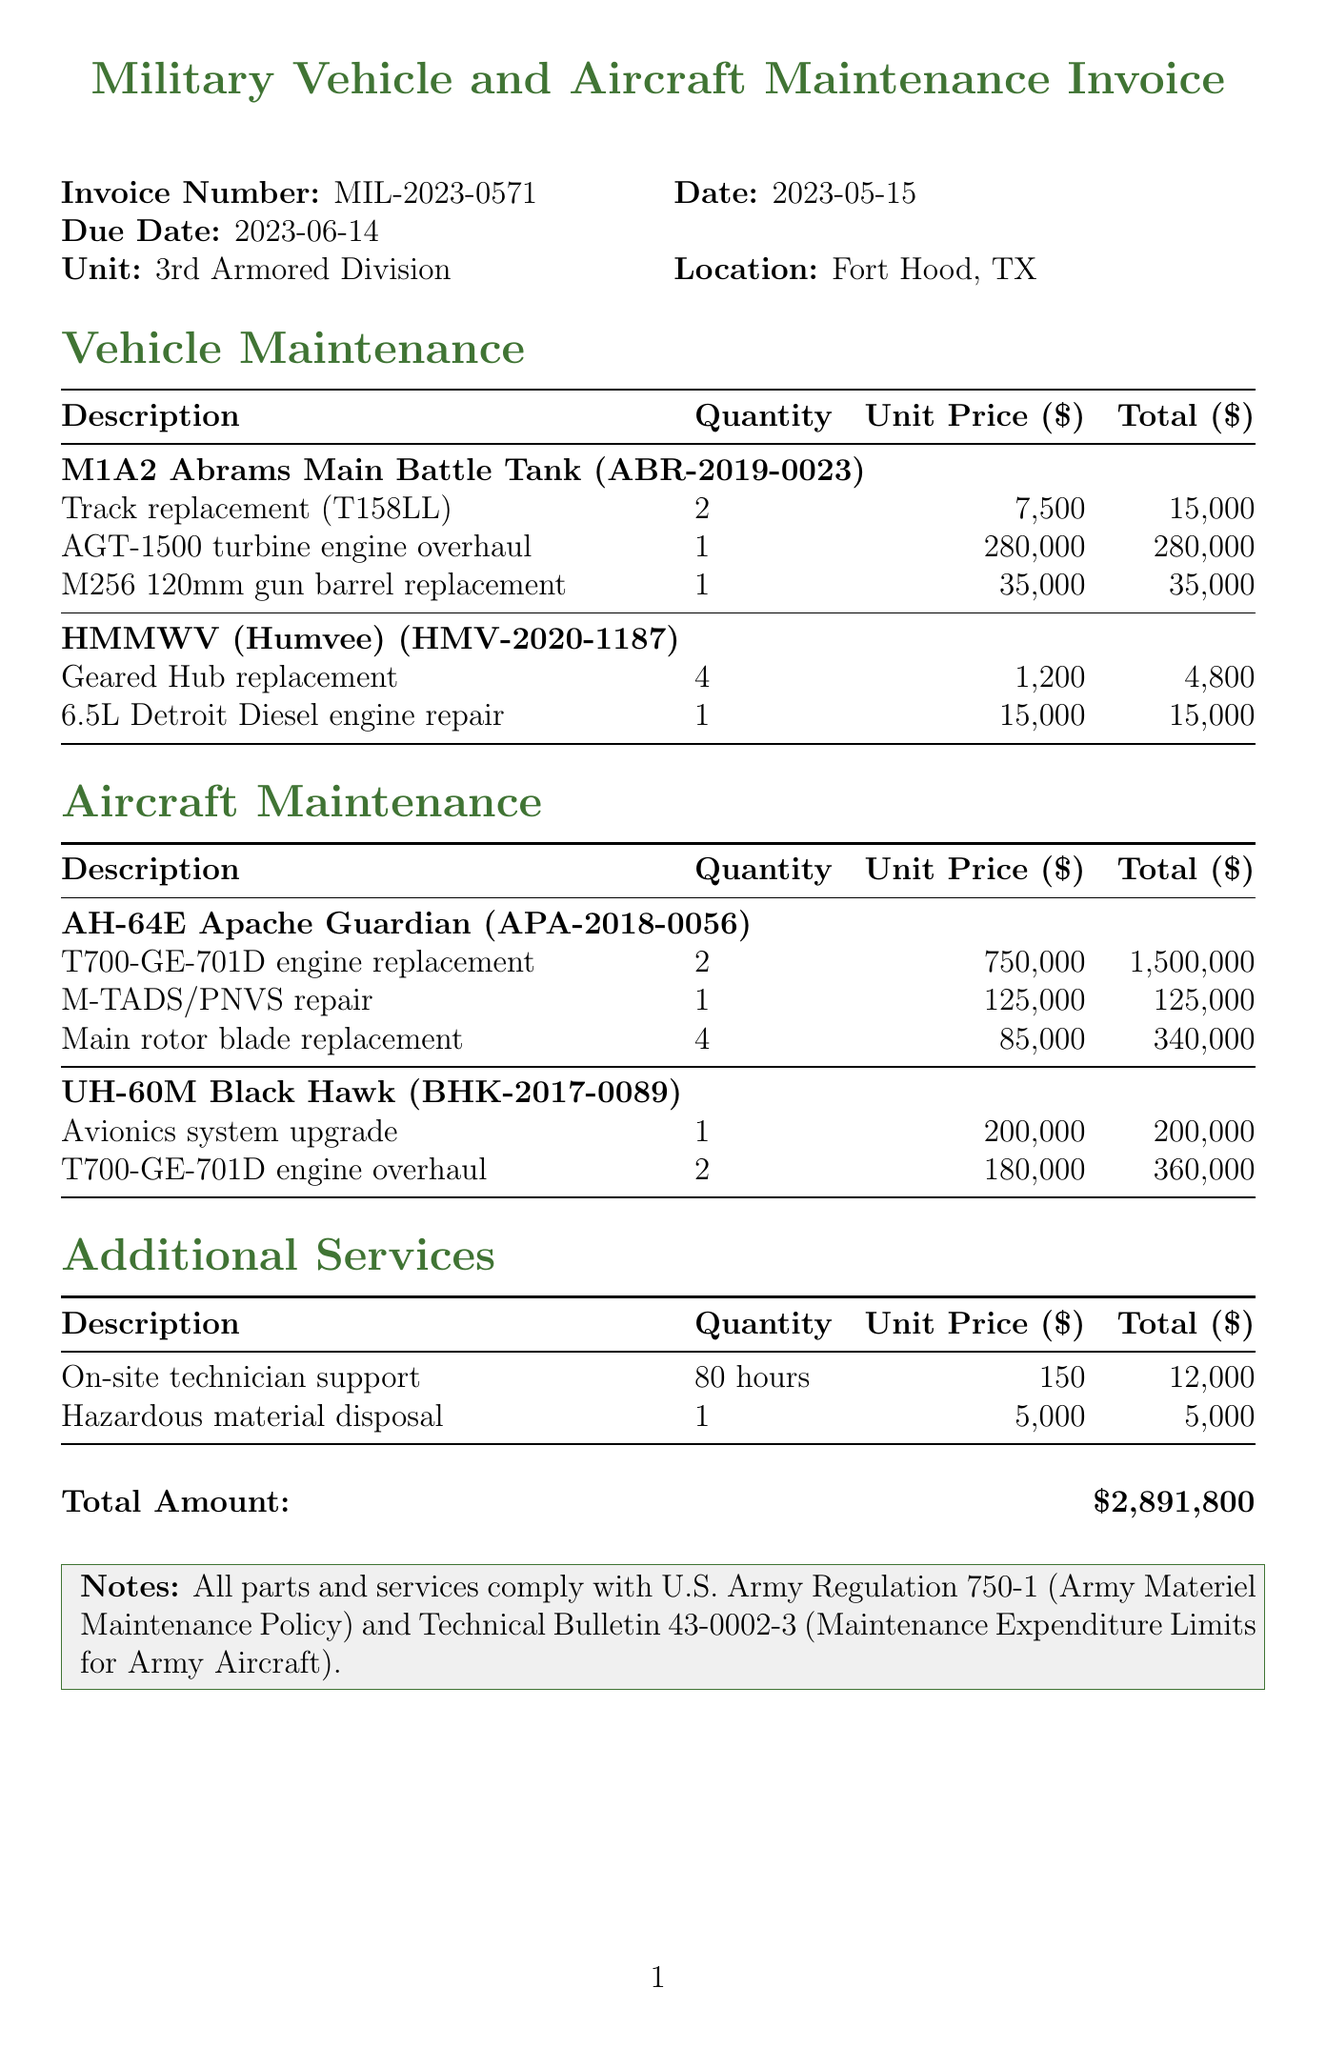What is the invoice number? The invoice number is provided at the top of the document, labeled clearly.
Answer: MIL-2023-0571 What is the total amount due? The total amount is listed at the bottom of the document, indicating the total cost of services rendered.
Answer: $2,891,800 What is the due date for payment? The due date is specified on the invoice alongside the issue date and other details.
Answer: 2023-06-14 How many hours of on-site technician support were billed? The document specifies the quantity of hours for this service in the additional services section.
Answer: 80 hours What type of vehicle is the AGT-1500 turbine engine overhaul for? The type of vehicle for this maintenance item is listed under the respective vehicle section.
Answer: M1A2 Abrams Main Battle Tank What maintenance item has the highest total cost? The item with the highest total cost is identified among all listed maintenance items in the document.
Answer: T700-GE-701D engine replacement Which aircraft had an avionics system upgrade? The aircraft that underwent this specific upgrade is mentioned in the aircraft maintenance section.
Answer: UH-60M Black Hawk How many main rotor blades were replaced on the AH-64E Apache Guardian? The document lists the quantity of main rotor blades replaced in the aircraft maintenance section.
Answer: 4 What is noted about compliance in the invoice? The notes section mentions the adherence to specific U.S. Army regulations regarding the maintenance performed.
Answer: Compliance with U.S. Army Regulation 750-1 and Technical Bulletin 43-0002-3 